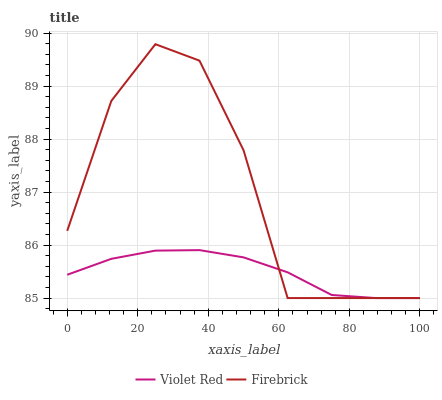Does Violet Red have the minimum area under the curve?
Answer yes or no. Yes. Does Firebrick have the maximum area under the curve?
Answer yes or no. Yes. Does Firebrick have the minimum area under the curve?
Answer yes or no. No. Is Violet Red the smoothest?
Answer yes or no. Yes. Is Firebrick the roughest?
Answer yes or no. Yes. Is Firebrick the smoothest?
Answer yes or no. No. Does Violet Red have the lowest value?
Answer yes or no. Yes. Does Firebrick have the highest value?
Answer yes or no. Yes. Does Violet Red intersect Firebrick?
Answer yes or no. Yes. Is Violet Red less than Firebrick?
Answer yes or no. No. Is Violet Red greater than Firebrick?
Answer yes or no. No. 